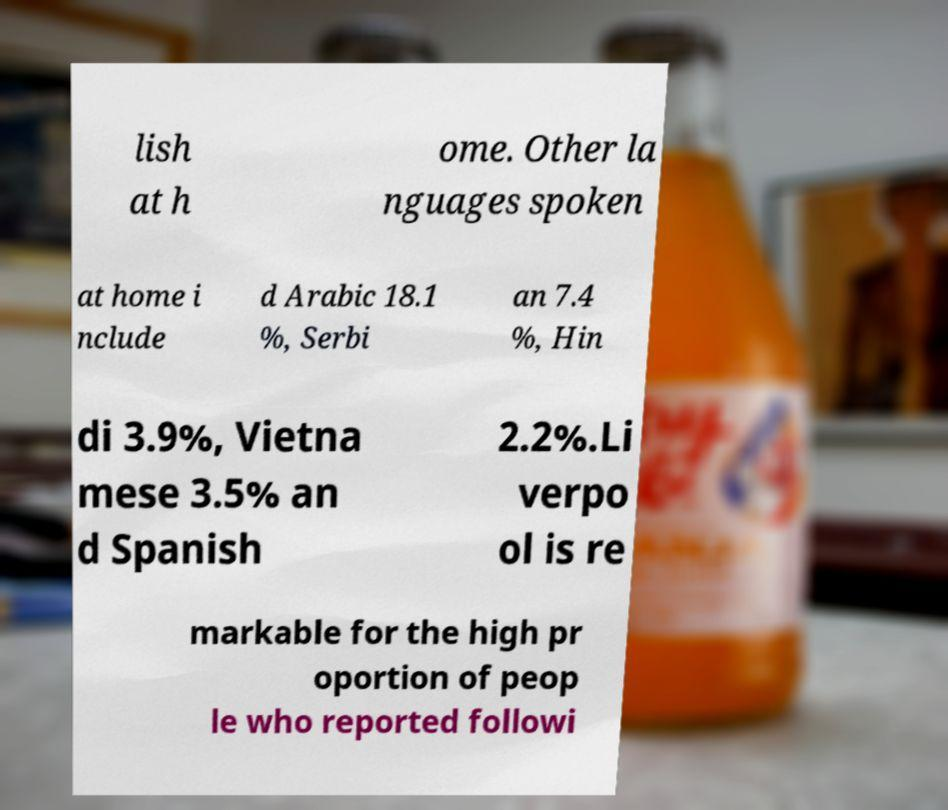Can you read and provide the text displayed in the image?This photo seems to have some interesting text. Can you extract and type it out for me? lish at h ome. Other la nguages spoken at home i nclude d Arabic 18.1 %, Serbi an 7.4 %, Hin di 3.9%, Vietna mese 3.5% an d Spanish 2.2%.Li verpo ol is re markable for the high pr oportion of peop le who reported followi 